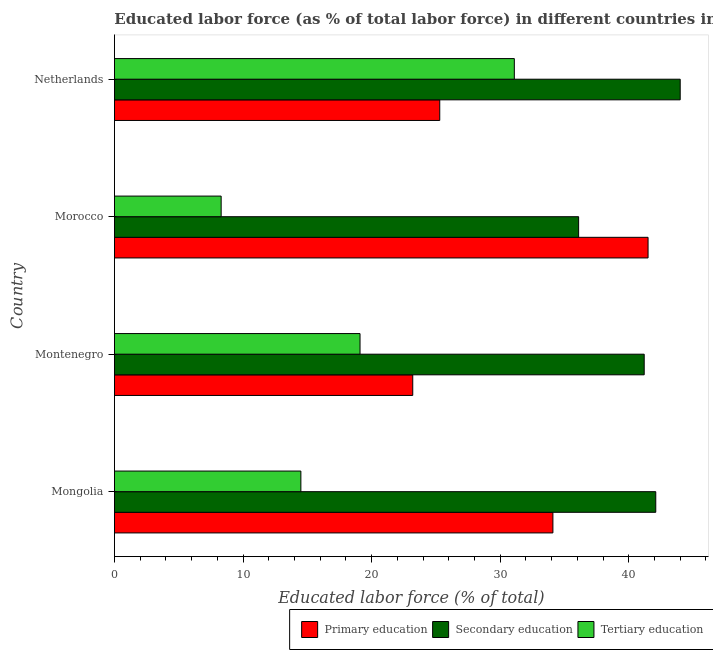Are the number of bars per tick equal to the number of legend labels?
Provide a short and direct response. Yes. How many bars are there on the 3rd tick from the top?
Ensure brevity in your answer.  3. In how many cases, is the number of bars for a given country not equal to the number of legend labels?
Keep it short and to the point. 0. What is the percentage of labor force who received tertiary education in Morocco?
Keep it short and to the point. 8.3. Across all countries, what is the maximum percentage of labor force who received tertiary education?
Offer a very short reply. 31.1. Across all countries, what is the minimum percentage of labor force who received tertiary education?
Your answer should be compact. 8.3. In which country was the percentage of labor force who received tertiary education maximum?
Your answer should be compact. Netherlands. In which country was the percentage of labor force who received primary education minimum?
Make the answer very short. Montenegro. What is the total percentage of labor force who received primary education in the graph?
Ensure brevity in your answer.  124.1. What is the difference between the percentage of labor force who received secondary education in Morocco and that in Netherlands?
Provide a succinct answer. -7.9. What is the difference between the percentage of labor force who received primary education in Mongolia and the percentage of labor force who received tertiary education in Netherlands?
Offer a very short reply. 3. What is the average percentage of labor force who received primary education per country?
Offer a terse response. 31.02. What is the difference between the percentage of labor force who received tertiary education and percentage of labor force who received primary education in Mongolia?
Make the answer very short. -19.6. In how many countries, is the percentage of labor force who received primary education greater than 20 %?
Provide a short and direct response. 4. What is the ratio of the percentage of labor force who received secondary education in Mongolia to that in Morocco?
Offer a terse response. 1.17. In how many countries, is the percentage of labor force who received tertiary education greater than the average percentage of labor force who received tertiary education taken over all countries?
Keep it short and to the point. 2. Is the sum of the percentage of labor force who received primary education in Morocco and Netherlands greater than the maximum percentage of labor force who received tertiary education across all countries?
Offer a terse response. Yes. What does the 1st bar from the top in Netherlands represents?
Provide a succinct answer. Tertiary education. What does the 3rd bar from the bottom in Netherlands represents?
Offer a terse response. Tertiary education. Is it the case that in every country, the sum of the percentage of labor force who received primary education and percentage of labor force who received secondary education is greater than the percentage of labor force who received tertiary education?
Your response must be concise. Yes. What is the difference between two consecutive major ticks on the X-axis?
Ensure brevity in your answer.  10. Does the graph contain any zero values?
Ensure brevity in your answer.  No. Does the graph contain grids?
Provide a short and direct response. No. What is the title of the graph?
Ensure brevity in your answer.  Educated labor force (as % of total labor force) in different countries in 2008. Does "Natural gas sources" appear as one of the legend labels in the graph?
Provide a short and direct response. No. What is the label or title of the X-axis?
Provide a short and direct response. Educated labor force (% of total). What is the label or title of the Y-axis?
Provide a succinct answer. Country. What is the Educated labor force (% of total) of Primary education in Mongolia?
Offer a terse response. 34.1. What is the Educated labor force (% of total) in Secondary education in Mongolia?
Give a very brief answer. 42.1. What is the Educated labor force (% of total) in Tertiary education in Mongolia?
Provide a short and direct response. 14.5. What is the Educated labor force (% of total) of Primary education in Montenegro?
Give a very brief answer. 23.2. What is the Educated labor force (% of total) in Secondary education in Montenegro?
Keep it short and to the point. 41.2. What is the Educated labor force (% of total) in Tertiary education in Montenegro?
Ensure brevity in your answer.  19.1. What is the Educated labor force (% of total) in Primary education in Morocco?
Provide a succinct answer. 41.5. What is the Educated labor force (% of total) in Secondary education in Morocco?
Provide a succinct answer. 36.1. What is the Educated labor force (% of total) of Tertiary education in Morocco?
Make the answer very short. 8.3. What is the Educated labor force (% of total) in Primary education in Netherlands?
Keep it short and to the point. 25.3. What is the Educated labor force (% of total) in Secondary education in Netherlands?
Make the answer very short. 44. What is the Educated labor force (% of total) of Tertiary education in Netherlands?
Keep it short and to the point. 31.1. Across all countries, what is the maximum Educated labor force (% of total) in Primary education?
Give a very brief answer. 41.5. Across all countries, what is the maximum Educated labor force (% of total) of Secondary education?
Give a very brief answer. 44. Across all countries, what is the maximum Educated labor force (% of total) of Tertiary education?
Provide a short and direct response. 31.1. Across all countries, what is the minimum Educated labor force (% of total) of Primary education?
Your response must be concise. 23.2. Across all countries, what is the minimum Educated labor force (% of total) in Secondary education?
Give a very brief answer. 36.1. Across all countries, what is the minimum Educated labor force (% of total) in Tertiary education?
Provide a short and direct response. 8.3. What is the total Educated labor force (% of total) in Primary education in the graph?
Provide a succinct answer. 124.1. What is the total Educated labor force (% of total) in Secondary education in the graph?
Ensure brevity in your answer.  163.4. What is the total Educated labor force (% of total) of Tertiary education in the graph?
Offer a terse response. 73. What is the difference between the Educated labor force (% of total) in Tertiary education in Mongolia and that in Montenegro?
Your answer should be compact. -4.6. What is the difference between the Educated labor force (% of total) in Primary education in Mongolia and that in Morocco?
Your answer should be compact. -7.4. What is the difference between the Educated labor force (% of total) in Tertiary education in Mongolia and that in Morocco?
Provide a succinct answer. 6.2. What is the difference between the Educated labor force (% of total) in Primary education in Mongolia and that in Netherlands?
Provide a succinct answer. 8.8. What is the difference between the Educated labor force (% of total) of Secondary education in Mongolia and that in Netherlands?
Provide a short and direct response. -1.9. What is the difference between the Educated labor force (% of total) of Tertiary education in Mongolia and that in Netherlands?
Make the answer very short. -16.6. What is the difference between the Educated labor force (% of total) of Primary education in Montenegro and that in Morocco?
Offer a terse response. -18.3. What is the difference between the Educated labor force (% of total) in Secondary education in Montenegro and that in Morocco?
Provide a succinct answer. 5.1. What is the difference between the Educated labor force (% of total) of Tertiary education in Montenegro and that in Morocco?
Your answer should be compact. 10.8. What is the difference between the Educated labor force (% of total) of Primary education in Montenegro and that in Netherlands?
Offer a terse response. -2.1. What is the difference between the Educated labor force (% of total) of Secondary education in Montenegro and that in Netherlands?
Make the answer very short. -2.8. What is the difference between the Educated labor force (% of total) in Tertiary education in Montenegro and that in Netherlands?
Your answer should be very brief. -12. What is the difference between the Educated labor force (% of total) of Tertiary education in Morocco and that in Netherlands?
Offer a very short reply. -22.8. What is the difference between the Educated labor force (% of total) in Primary education in Mongolia and the Educated labor force (% of total) in Tertiary education in Montenegro?
Keep it short and to the point. 15. What is the difference between the Educated labor force (% of total) of Primary education in Mongolia and the Educated labor force (% of total) of Secondary education in Morocco?
Your response must be concise. -2. What is the difference between the Educated labor force (% of total) in Primary education in Mongolia and the Educated labor force (% of total) in Tertiary education in Morocco?
Your answer should be very brief. 25.8. What is the difference between the Educated labor force (% of total) of Secondary education in Mongolia and the Educated labor force (% of total) of Tertiary education in Morocco?
Ensure brevity in your answer.  33.8. What is the difference between the Educated labor force (% of total) of Primary education in Mongolia and the Educated labor force (% of total) of Tertiary education in Netherlands?
Give a very brief answer. 3. What is the difference between the Educated labor force (% of total) in Secondary education in Mongolia and the Educated labor force (% of total) in Tertiary education in Netherlands?
Provide a succinct answer. 11. What is the difference between the Educated labor force (% of total) of Primary education in Montenegro and the Educated labor force (% of total) of Tertiary education in Morocco?
Give a very brief answer. 14.9. What is the difference between the Educated labor force (% of total) in Secondary education in Montenegro and the Educated labor force (% of total) in Tertiary education in Morocco?
Your answer should be compact. 32.9. What is the difference between the Educated labor force (% of total) in Primary education in Montenegro and the Educated labor force (% of total) in Secondary education in Netherlands?
Make the answer very short. -20.8. What is the difference between the Educated labor force (% of total) of Primary education in Morocco and the Educated labor force (% of total) of Secondary education in Netherlands?
Offer a terse response. -2.5. What is the difference between the Educated labor force (% of total) of Primary education in Morocco and the Educated labor force (% of total) of Tertiary education in Netherlands?
Your response must be concise. 10.4. What is the difference between the Educated labor force (% of total) in Secondary education in Morocco and the Educated labor force (% of total) in Tertiary education in Netherlands?
Make the answer very short. 5. What is the average Educated labor force (% of total) in Primary education per country?
Make the answer very short. 31.02. What is the average Educated labor force (% of total) of Secondary education per country?
Keep it short and to the point. 40.85. What is the average Educated labor force (% of total) of Tertiary education per country?
Provide a succinct answer. 18.25. What is the difference between the Educated labor force (% of total) of Primary education and Educated labor force (% of total) of Tertiary education in Mongolia?
Make the answer very short. 19.6. What is the difference between the Educated labor force (% of total) in Secondary education and Educated labor force (% of total) in Tertiary education in Mongolia?
Make the answer very short. 27.6. What is the difference between the Educated labor force (% of total) of Primary education and Educated labor force (% of total) of Tertiary education in Montenegro?
Give a very brief answer. 4.1. What is the difference between the Educated labor force (% of total) in Secondary education and Educated labor force (% of total) in Tertiary education in Montenegro?
Give a very brief answer. 22.1. What is the difference between the Educated labor force (% of total) in Primary education and Educated labor force (% of total) in Secondary education in Morocco?
Keep it short and to the point. 5.4. What is the difference between the Educated labor force (% of total) in Primary education and Educated labor force (% of total) in Tertiary education in Morocco?
Provide a succinct answer. 33.2. What is the difference between the Educated labor force (% of total) of Secondary education and Educated labor force (% of total) of Tertiary education in Morocco?
Provide a succinct answer. 27.8. What is the difference between the Educated labor force (% of total) of Primary education and Educated labor force (% of total) of Secondary education in Netherlands?
Offer a terse response. -18.7. What is the difference between the Educated labor force (% of total) of Primary education and Educated labor force (% of total) of Tertiary education in Netherlands?
Your answer should be compact. -5.8. What is the ratio of the Educated labor force (% of total) of Primary education in Mongolia to that in Montenegro?
Provide a succinct answer. 1.47. What is the ratio of the Educated labor force (% of total) of Secondary education in Mongolia to that in Montenegro?
Your answer should be compact. 1.02. What is the ratio of the Educated labor force (% of total) of Tertiary education in Mongolia to that in Montenegro?
Give a very brief answer. 0.76. What is the ratio of the Educated labor force (% of total) of Primary education in Mongolia to that in Morocco?
Ensure brevity in your answer.  0.82. What is the ratio of the Educated labor force (% of total) in Secondary education in Mongolia to that in Morocco?
Offer a terse response. 1.17. What is the ratio of the Educated labor force (% of total) of Tertiary education in Mongolia to that in Morocco?
Keep it short and to the point. 1.75. What is the ratio of the Educated labor force (% of total) of Primary education in Mongolia to that in Netherlands?
Keep it short and to the point. 1.35. What is the ratio of the Educated labor force (% of total) in Secondary education in Mongolia to that in Netherlands?
Ensure brevity in your answer.  0.96. What is the ratio of the Educated labor force (% of total) in Tertiary education in Mongolia to that in Netherlands?
Provide a short and direct response. 0.47. What is the ratio of the Educated labor force (% of total) in Primary education in Montenegro to that in Morocco?
Offer a very short reply. 0.56. What is the ratio of the Educated labor force (% of total) of Secondary education in Montenegro to that in Morocco?
Make the answer very short. 1.14. What is the ratio of the Educated labor force (% of total) of Tertiary education in Montenegro to that in Morocco?
Your response must be concise. 2.3. What is the ratio of the Educated labor force (% of total) of Primary education in Montenegro to that in Netherlands?
Give a very brief answer. 0.92. What is the ratio of the Educated labor force (% of total) in Secondary education in Montenegro to that in Netherlands?
Keep it short and to the point. 0.94. What is the ratio of the Educated labor force (% of total) in Tertiary education in Montenegro to that in Netherlands?
Provide a succinct answer. 0.61. What is the ratio of the Educated labor force (% of total) of Primary education in Morocco to that in Netherlands?
Your response must be concise. 1.64. What is the ratio of the Educated labor force (% of total) in Secondary education in Morocco to that in Netherlands?
Your answer should be very brief. 0.82. What is the ratio of the Educated labor force (% of total) of Tertiary education in Morocco to that in Netherlands?
Provide a succinct answer. 0.27. What is the difference between the highest and the second highest Educated labor force (% of total) of Secondary education?
Give a very brief answer. 1.9. What is the difference between the highest and the second highest Educated labor force (% of total) in Tertiary education?
Your answer should be very brief. 12. What is the difference between the highest and the lowest Educated labor force (% of total) of Primary education?
Make the answer very short. 18.3. What is the difference between the highest and the lowest Educated labor force (% of total) in Secondary education?
Keep it short and to the point. 7.9. What is the difference between the highest and the lowest Educated labor force (% of total) of Tertiary education?
Make the answer very short. 22.8. 